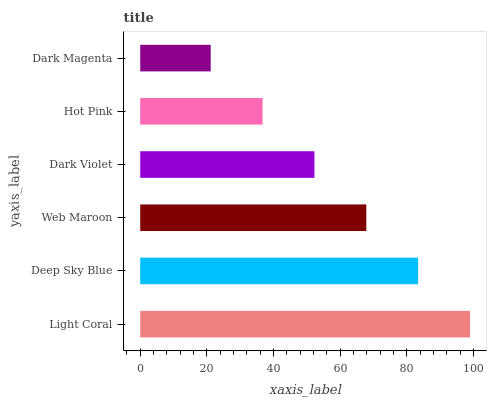Is Dark Magenta the minimum?
Answer yes or no. Yes. Is Light Coral the maximum?
Answer yes or no. Yes. Is Deep Sky Blue the minimum?
Answer yes or no. No. Is Deep Sky Blue the maximum?
Answer yes or no. No. Is Light Coral greater than Deep Sky Blue?
Answer yes or no. Yes. Is Deep Sky Blue less than Light Coral?
Answer yes or no. Yes. Is Deep Sky Blue greater than Light Coral?
Answer yes or no. No. Is Light Coral less than Deep Sky Blue?
Answer yes or no. No. Is Web Maroon the high median?
Answer yes or no. Yes. Is Dark Violet the low median?
Answer yes or no. Yes. Is Deep Sky Blue the high median?
Answer yes or no. No. Is Web Maroon the low median?
Answer yes or no. No. 